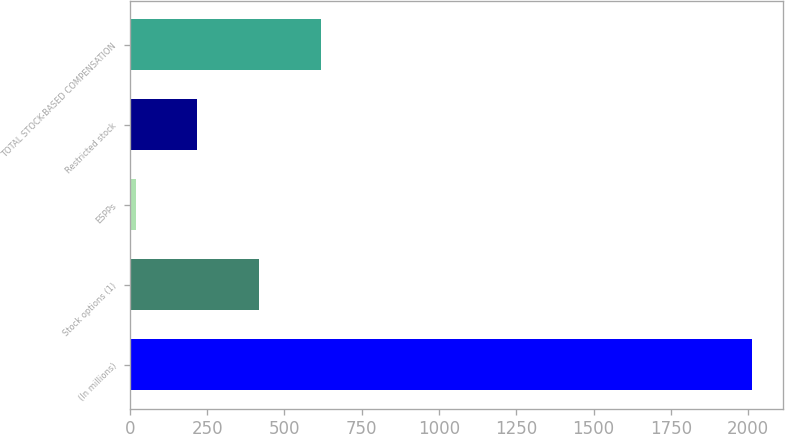Convert chart to OTSL. <chart><loc_0><loc_0><loc_500><loc_500><bar_chart><fcel>(In millions)<fcel>Stock options (1)<fcel>ESPPs<fcel>Restricted stock<fcel>TOTAL STOCK-BASED COMPENSATION<nl><fcel>2013<fcel>417.8<fcel>19<fcel>218.4<fcel>617.2<nl></chart> 